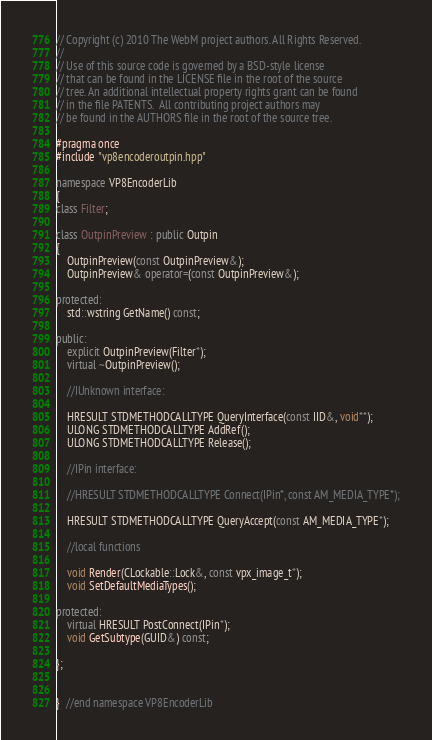Convert code to text. <code><loc_0><loc_0><loc_500><loc_500><_C++_>// Copyright (c) 2010 The WebM project authors. All Rights Reserved.
//
// Use of this source code is governed by a BSD-style license
// that can be found in the LICENSE file in the root of the source
// tree. An additional intellectual property rights grant can be found
// in the file PATENTS.  All contributing project authors may
// be found in the AUTHORS file in the root of the source tree.

#pragma once
#include "vp8encoderoutpin.hpp"

namespace VP8EncoderLib
{
class Filter;

class OutpinPreview : public Outpin
{
    OutpinPreview(const OutpinPreview&);
    OutpinPreview& operator=(const OutpinPreview&);

protected:
    std::wstring GetName() const;

public:
    explicit OutpinPreview(Filter*);
    virtual ~OutpinPreview();

    //IUnknown interface:

    HRESULT STDMETHODCALLTYPE QueryInterface(const IID&, void**);
    ULONG STDMETHODCALLTYPE AddRef();
    ULONG STDMETHODCALLTYPE Release();

    //IPin interface:

    //HRESULT STDMETHODCALLTYPE Connect(IPin*, const AM_MEDIA_TYPE*);

    HRESULT STDMETHODCALLTYPE QueryAccept(const AM_MEDIA_TYPE*);

    //local functions

    void Render(CLockable::Lock&, const vpx_image_t*);
    void SetDefaultMediaTypes();

protected:
    virtual HRESULT PostConnect(IPin*);
    void GetSubtype(GUID&) const;

};


}  //end namespace VP8EncoderLib
</code> 